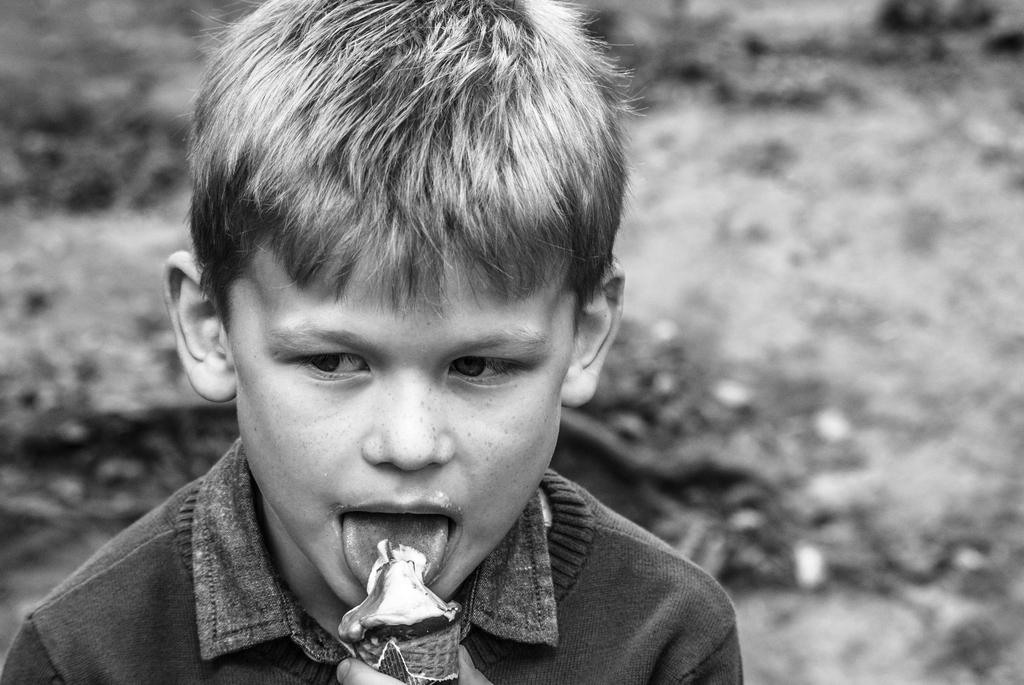Who is the main subject in the image? There is a boy in the image. What is the boy doing in the image? The boy is eating ice cream. Can you describe the background of the image? The background of the image is blurred. What type of camera is the boy using to take pictures in the image? There is no camera present in the image, and the boy is not taking pictures; he is eating ice cream. 